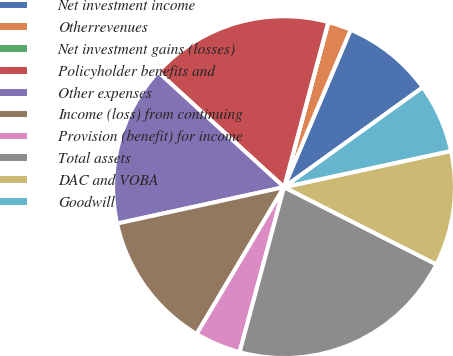Convert chart. <chart><loc_0><loc_0><loc_500><loc_500><pie_chart><fcel>Net investment income<fcel>Otherrevenues<fcel>Net investment gains (losses)<fcel>Policyholder benefits and<fcel>Other expenses<fcel>Income (loss) from continuing<fcel>Provision (benefit) for income<fcel>Total assets<fcel>DAC and VOBA<fcel>Goodwill<nl><fcel>8.7%<fcel>2.19%<fcel>0.02%<fcel>17.38%<fcel>15.21%<fcel>13.04%<fcel>4.36%<fcel>21.72%<fcel>10.87%<fcel>6.53%<nl></chart> 